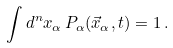<formula> <loc_0><loc_0><loc_500><loc_500>\int d ^ { n } x _ { \alpha } \, P _ { \alpha } ( \vec { x } _ { \alpha } , t ) = 1 \, .</formula> 